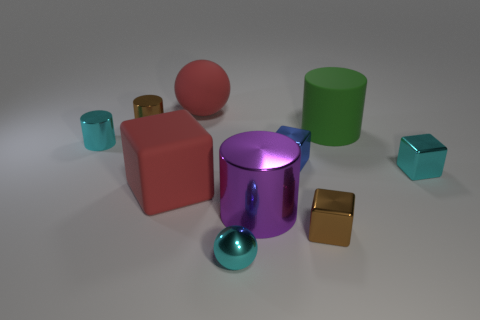What material is the tiny cylinder that is the same color as the small metal ball?
Your response must be concise. Metal. How many objects are either tiny cyan blocks or cylinders behind the purple shiny cylinder?
Your response must be concise. 4. Is the big cylinder to the left of the blue metallic cube made of the same material as the large green cylinder?
Your answer should be compact. No. The tiny cube that is in front of the small cyan shiny object that is to the right of the shiny sphere is made of what material?
Offer a terse response. Metal. Are there more large green rubber things that are behind the large red cube than small brown metallic cylinders in front of the brown cylinder?
Make the answer very short. Yes. What size is the cyan cylinder?
Offer a very short reply. Small. There is a block to the left of the small ball; is it the same color as the big rubber sphere?
Provide a succinct answer. Yes. There is a tiny metal cube left of the tiny brown cube; are there any large rubber cubes on the right side of it?
Offer a very short reply. No. Are there fewer red things to the right of the purple object than brown things that are behind the blue metal block?
Provide a succinct answer. Yes. There is a metal object behind the big matte thing right of the metal cube that is in front of the big purple metallic cylinder; what is its size?
Your response must be concise. Small. 